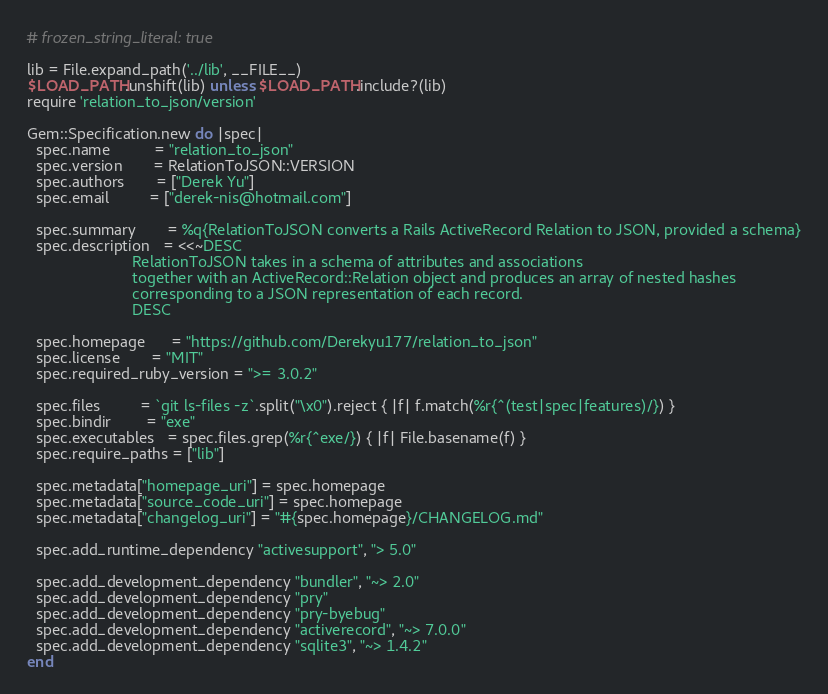Convert code to text. <code><loc_0><loc_0><loc_500><loc_500><_Ruby_># frozen_string_literal: true

lib = File.expand_path('../lib', __FILE__)
$LOAD_PATH.unshift(lib) unless $LOAD_PATH.include?(lib)
require 'relation_to_json/version'

Gem::Specification.new do |spec|
  spec.name          = "relation_to_json"
  spec.version       = RelationToJSON::VERSION
  spec.authors       = ["Derek Yu"]
  spec.email         = ["derek-nis@hotmail.com"]

  spec.summary       = %q{RelationToJSON converts a Rails ActiveRecord Relation to JSON, provided a schema}
  spec.description   = <<~DESC
                        RelationToJSON takes in a schema of attributes and associations
                        together with an ActiveRecord::Relation object and produces an array of nested hashes
                        corresponding to a JSON representation of each record.
                        DESC

  spec.homepage      = "https://github.com/Derekyu177/relation_to_json"
  spec.license       = "MIT"
  spec.required_ruby_version = ">= 3.0.2"

  spec.files         = `git ls-files -z`.split("\x0").reject { |f| f.match(%r{^(test|spec|features)/}) }
  spec.bindir        = "exe"
  spec.executables   = spec.files.grep(%r{^exe/}) { |f| File.basename(f) }
  spec.require_paths = ["lib"]

  spec.metadata["homepage_uri"] = spec.homepage
  spec.metadata["source_code_uri"] = spec.homepage
  spec.metadata["changelog_uri"] = "#{spec.homepage}/CHANGELOG.md"

  spec.add_runtime_dependency "activesupport", "> 5.0"

  spec.add_development_dependency "bundler", "~> 2.0"
  spec.add_development_dependency "pry"
  spec.add_development_dependency "pry-byebug"
  spec.add_development_dependency "activerecord", "~> 7.0.0"
  spec.add_development_dependency "sqlite3", "~> 1.4.2"
end
</code> 